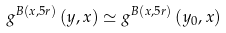<formula> <loc_0><loc_0><loc_500><loc_500>g ^ { B \left ( x , 5 r \right ) } \left ( y , x \right ) \simeq g ^ { B \left ( x , 5 r \right ) } \left ( y _ { 0 } , x \right )</formula> 